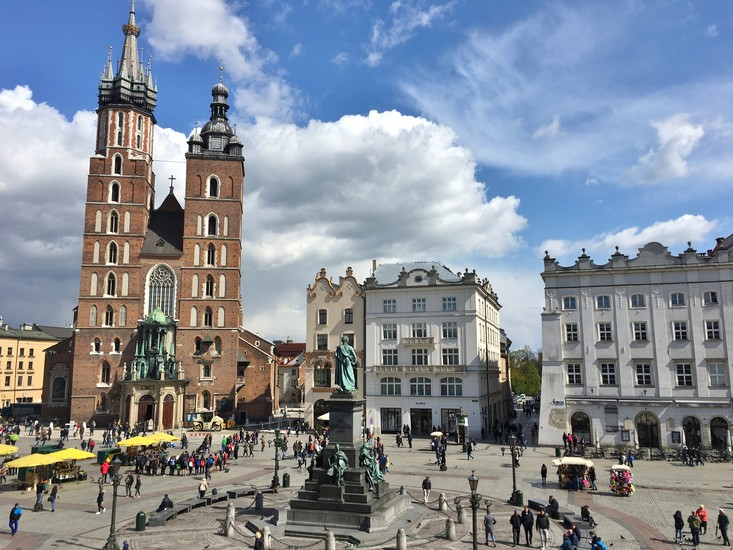Can you describe the main features of this image for me? The image depicts the lively Main Market Square in Krakow, Poland, captured from an elevated perspective. People and vendors fill the square, painting a lively and dynamic scene. Colorful umbrellas and stalls add vibrancy to the area. Surrounding the square are charming historic buildings, each showcasing uniquely ornate facades in an array of colors.

Dominating the view is the stunning St. Mary's Basilica, a towering Gothic structure with two asymmetrical spires that reach into the sky, symbolizing the rich architectural heritage of Krakow. The basilica's intricate design and brickwork stand out prominently.

At the center of the square, a bronze statue of the renowned Polish poet, Adam Mickiewicz, stands on a high pedestal surrounded by smaller statues symbolizing different artistic realms, underscoring the cultural significance and historical pride of the city. The overall atmosphere exudes a harmonious blend of history, culture, and vibrant modern life. 